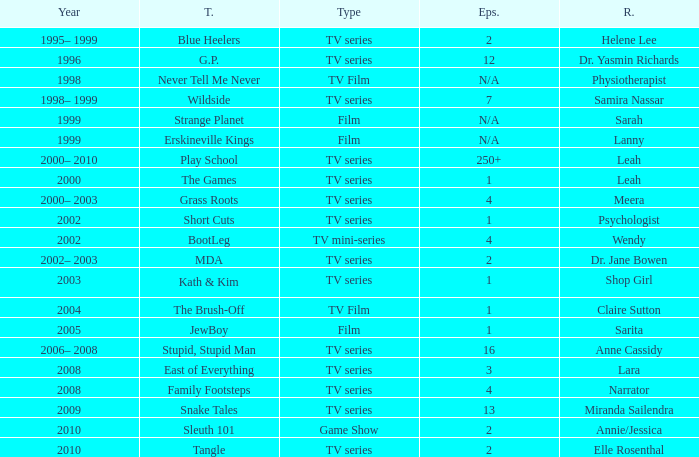What episode is called jewboy 1.0. 